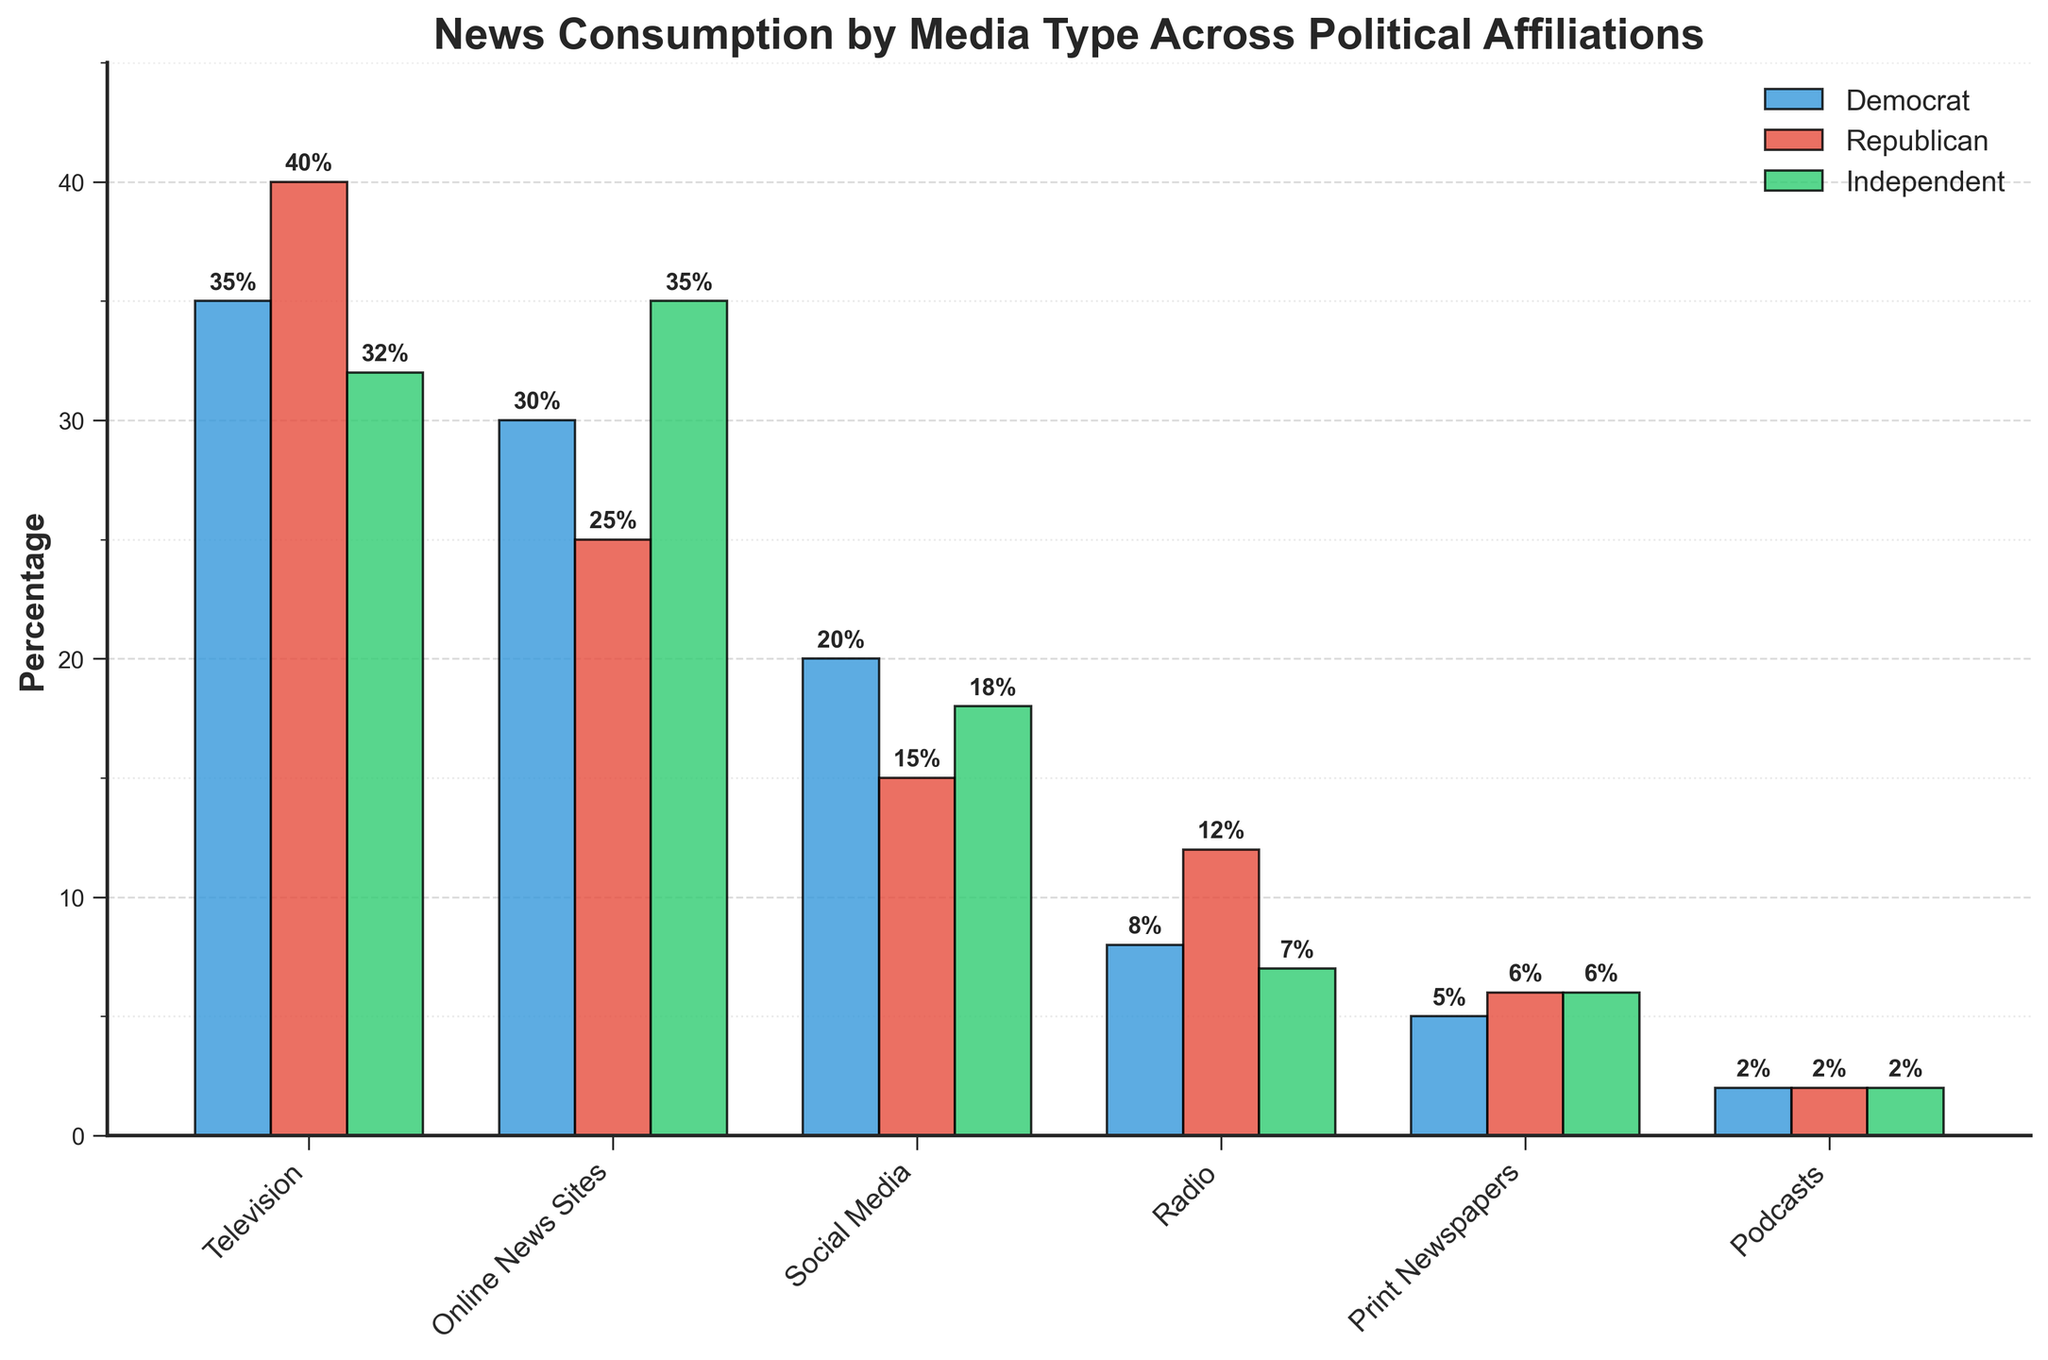Which media type has the highest percentage of news consumption among Republicans? Looking at the bar chart, identify the tallest bar in the segment labeled "Republican" and note the media type it corresponds to. Television has the highest percentage among Republicans at 40%.
Answer: Television Which political affiliation consumes print newspapers the least? Compare the heights of the bars labeled "Print Newspapers" across Democrats, Republicans, and Independents to find the shortest one. Democrats have the lowest consumption at 5%.
Answer: Democrat What is the combined percentage of social media and online news sites consumption for Independents? Find the heights of the bars for "Social Media" (18%) and "Online News Sites" (35%) in the Independent section, then add them together. 18% + 35% = 53%
Answer: 53% Do Republicans consume more radio news than Democrats? By how much? Compare the heights of the bars labeled "Radio" for Republicans (12%) and Democrats (8%), then compute the difference. Republicans consume 12% - 8% = 4% more radio news.
Answer: Yes, by 4% Which political affiliation has the lowest total consumption for all media types combined? Sum the heights of all bars for each political affiliation:
- Democrats: 35 + 30 + 20 + 8 + 5 + 2 = 100%
- Republicans: 40 + 25 + 15 + 12 + 6 + 2 = 100%
- Independents: 32 + 35 + 18 + 7 + 6 + 2 = 100%
All affiliations have equal total consumption.
Answer: Equal (each 100%) In which media type is the percentage of news consumption equal for all political affiliations? Observe the bars for each media type and find one where all bars are of equal height. Podcasts have an equal percentage of 2% across all affiliations.
Answer: Podcasts Which political affiliation consumes the least online news sites? Compare the heights of the bars labeled "Online News Sites" for Democrats (30%), Republicans (25%), and Independents (35%). Republicans have the lowest at 25%.
Answer: Republican What is the difference in news consumption via television between Democrats and Independents? Compare the heights of the bars labeled "Television" for Democrats (35%) and Independents (32%), and compute the difference. 35% - 32% = 3%.
Answer: 3% Which political affiliation uses social media the most for news consumption? Look at the bars labeled "Social Media" and identify which is the tallest among the affiliations. Democrats have the highest at 20%.
Answer: Democrat 